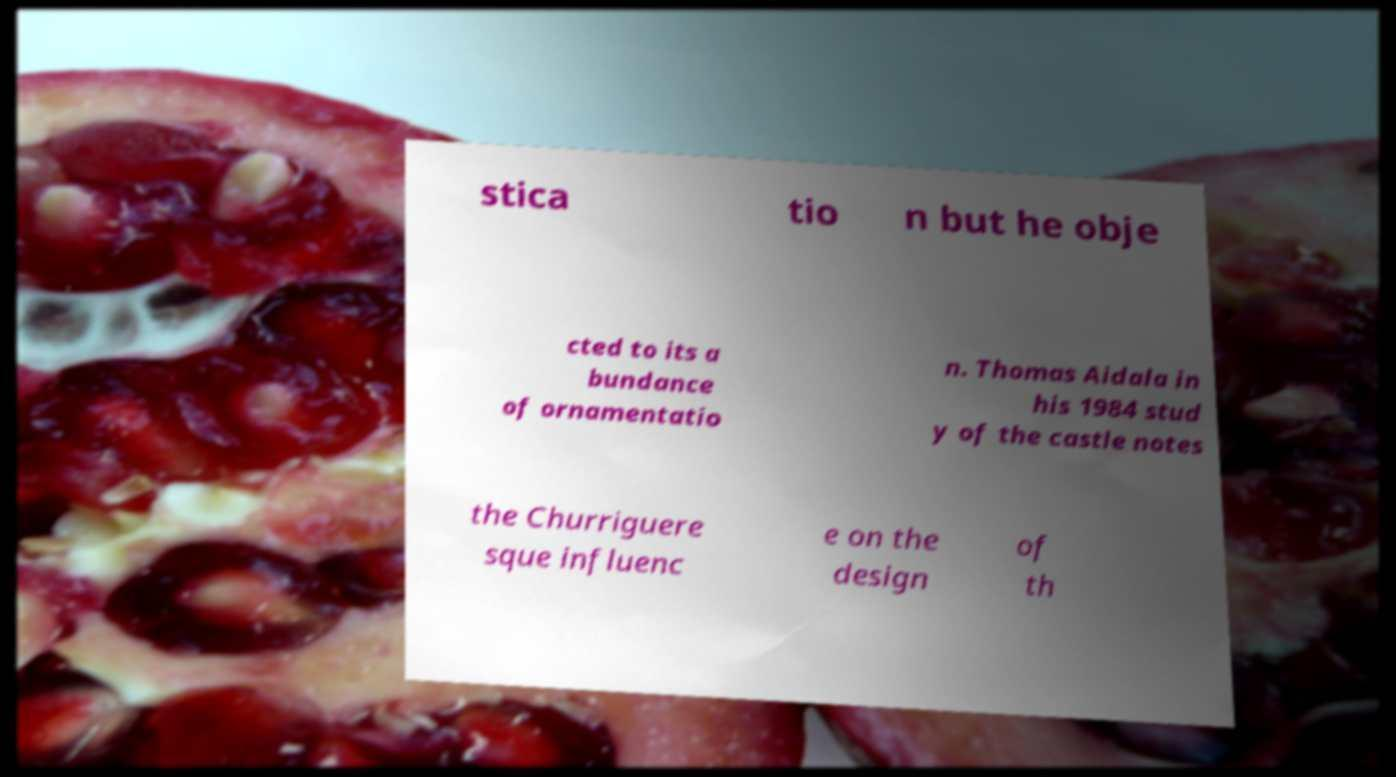I need the written content from this picture converted into text. Can you do that? stica tio n but he obje cted to its a bundance of ornamentatio n. Thomas Aidala in his 1984 stud y of the castle notes the Churriguere sque influenc e on the design of th 